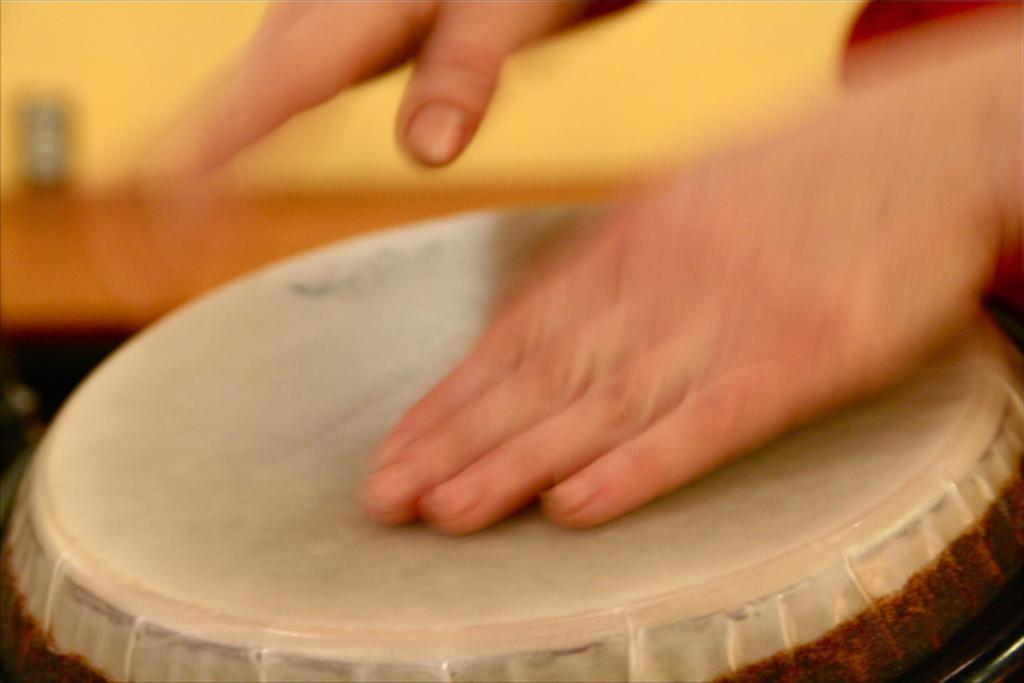Describe this image in one or two sentences. In this picture we can see a person playing tabla, there is a blurry background. 